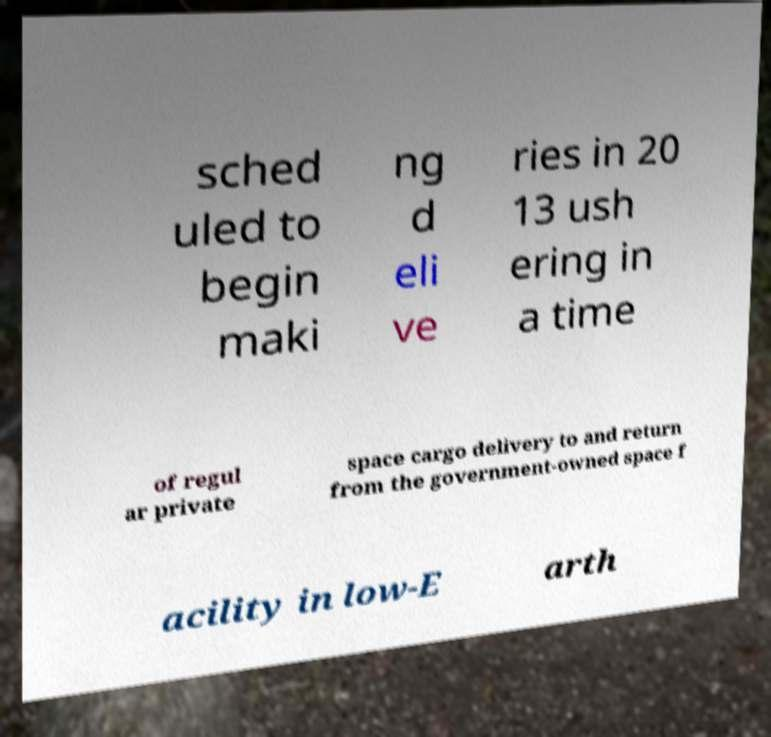Please identify and transcribe the text found in this image. sched uled to begin maki ng d eli ve ries in 20 13 ush ering in a time of regul ar private space cargo delivery to and return from the government-owned space f acility in low-E arth 